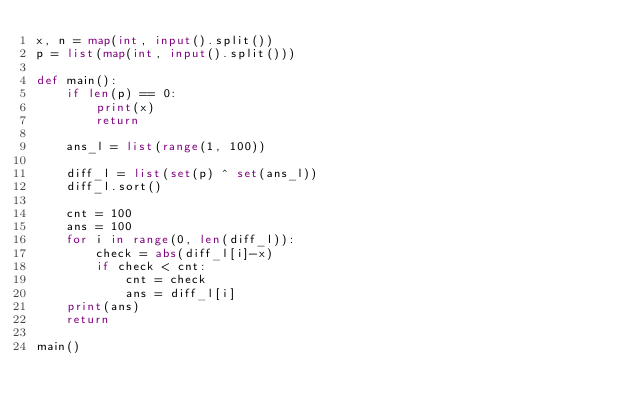Convert code to text. <code><loc_0><loc_0><loc_500><loc_500><_Python_>x, n = map(int, input().split())
p = list(map(int, input().split()))

def main():
    if len(p) == 0:
        print(x)
        return

    ans_l = list(range(1, 100))

    diff_l = list(set(p) ^ set(ans_l))
    diff_l.sort()

    cnt = 100
    ans = 100
    for i in range(0, len(diff_l)):
        check = abs(diff_l[i]-x)
        if check < cnt:
            cnt = check
            ans = diff_l[i]
    print(ans)
    return

main()</code> 